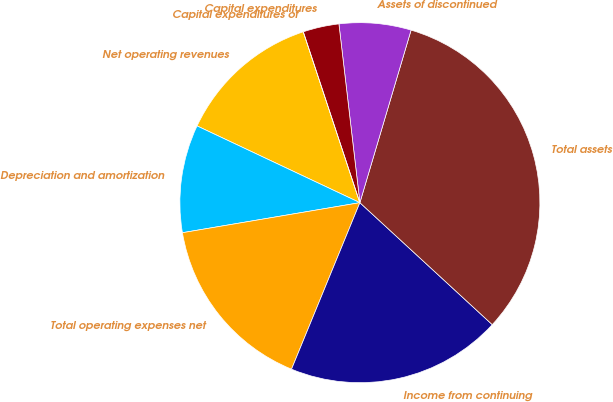Convert chart. <chart><loc_0><loc_0><loc_500><loc_500><pie_chart><fcel>Net operating revenues<fcel>Depreciation and amortization<fcel>Total operating expenses net<fcel>Income from continuing<fcel>Total assets<fcel>Assets of discontinued<fcel>Capital expenditures<fcel>Capital expenditures of<nl><fcel>12.9%<fcel>9.68%<fcel>16.13%<fcel>19.35%<fcel>32.26%<fcel>6.45%<fcel>3.23%<fcel>0.0%<nl></chart> 